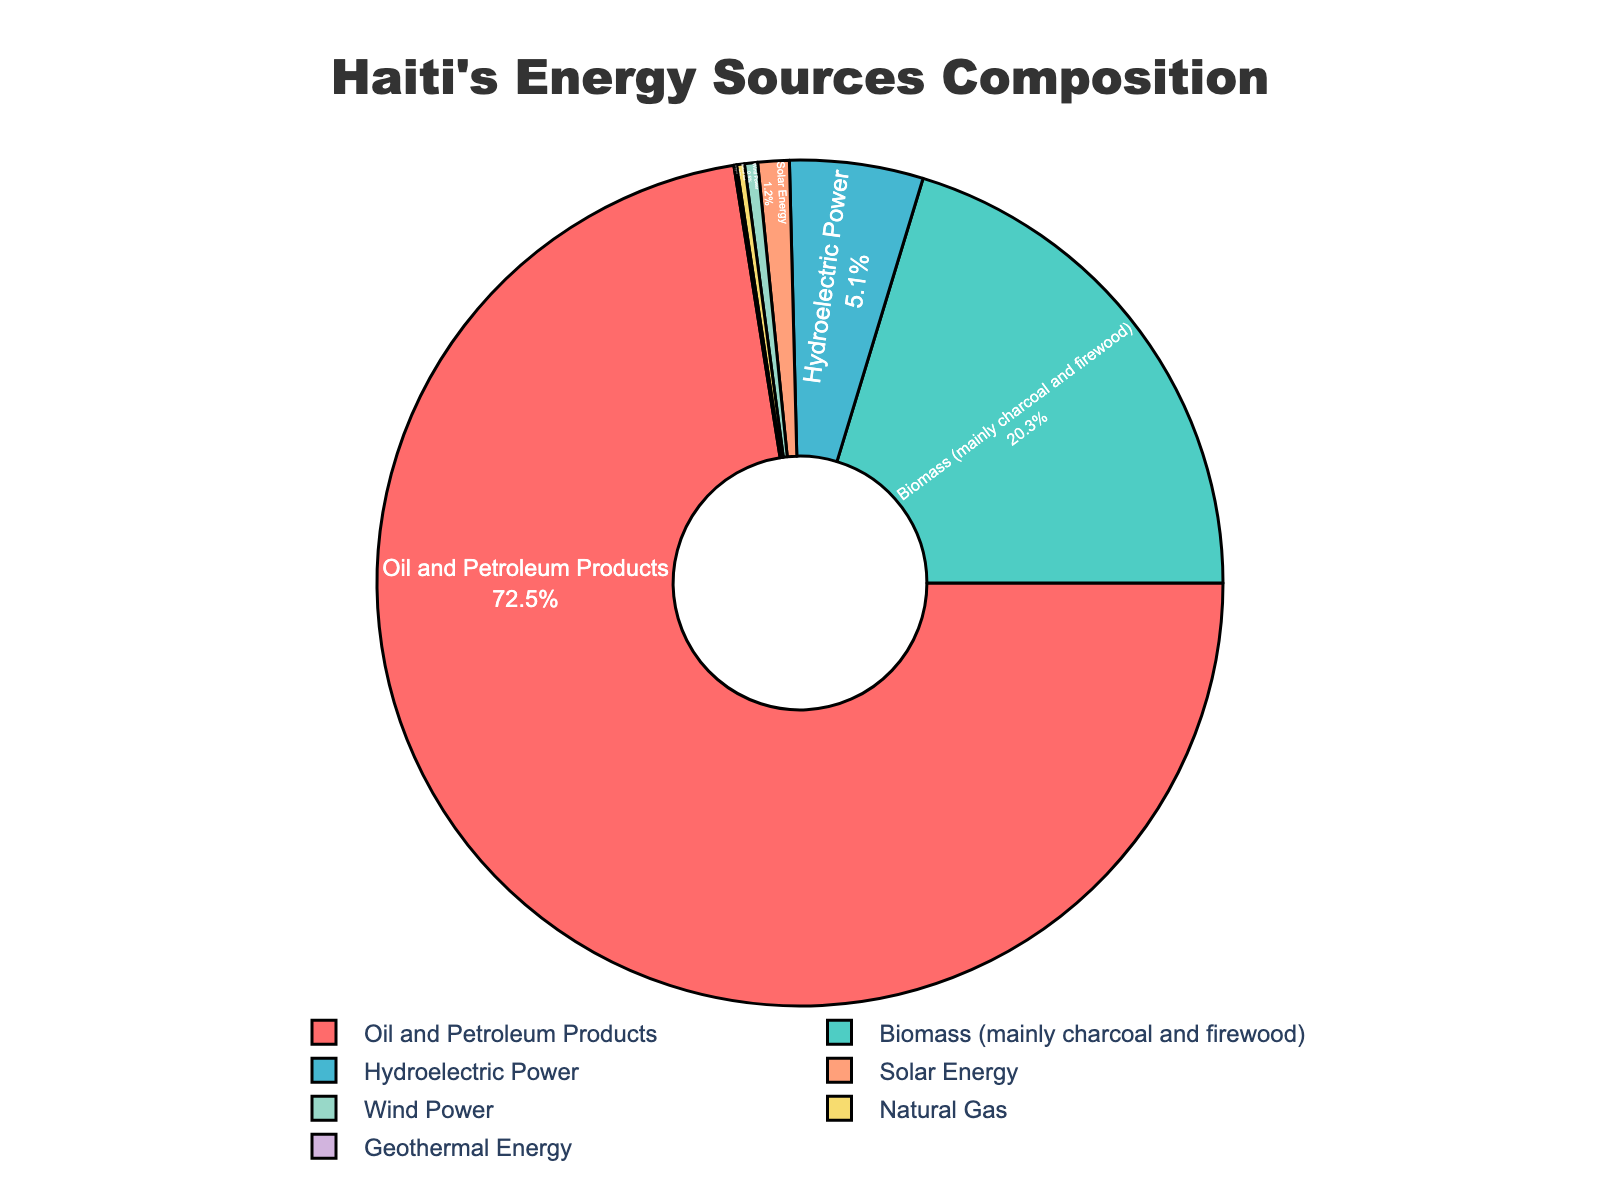What is the largest energy source in Haiti's energy composition? The largest energy source is represented by the sector with the highest percentage. From the pie chart, "Oil and Petroleum Products" has the largest segment.
Answer: Oil and Petroleum Products What percentage of Haiti's energy comes from renewable sources? Renewable energy sources include Hydro Power, Solar Energy, Wind Power, and Geothermal Energy. Add the percentages: 5.1 + 1.2 + 0.5 + 0.1 = 6.9%.
Answer: 6.9% How does the percentage of biomass compare to hydroelectric power? The pie chart shows biomass at 20.3% and hydroelectric power at 5.1%. To compare, subtract the smaller from the larger percentage. The difference is 20.3% - 5.1% = 15.2%.
Answer: Biomass is 15.2% higher What are the least common energy sources in Haiti? The least common sources are represented by the smallest segments in the pie chart. Natural Gas and Geothermal Energy have the smallest percentages of 0.3% and 0.1%, respectively.
Answer: Natural Gas and Geothermal Energy What is the combined percentage of oil, biomass, and hydroelectric power? Add the percentages for these sources: 72.5% (Oil) + 20.3% (Biomass) + 5.1% (Hydroelectric) = 97.9%.
Answer: 97.9% What visual attribute distinguishes the segment representing solar energy? Solar Energy's segment can be distinguished by its color and label inside the pie chart. It is colored differently (light orange) and shows both the label and the percentage value (1.2%) inside the segment.
Answer: Light Orange Is the percentage of wind power greater than that of natural gas? From the pie chart, Wind Power has a percentage of 0.5% and Natural Gas has 0.3%. Since 0.5% is greater than 0.3%, the answer is yes.
Answer: Yes Which energy source has a percentage closest to 1%? The pie chart shows Solar Energy at 1.2%, which is the closest to 1%.
Answer: Solar Energy 